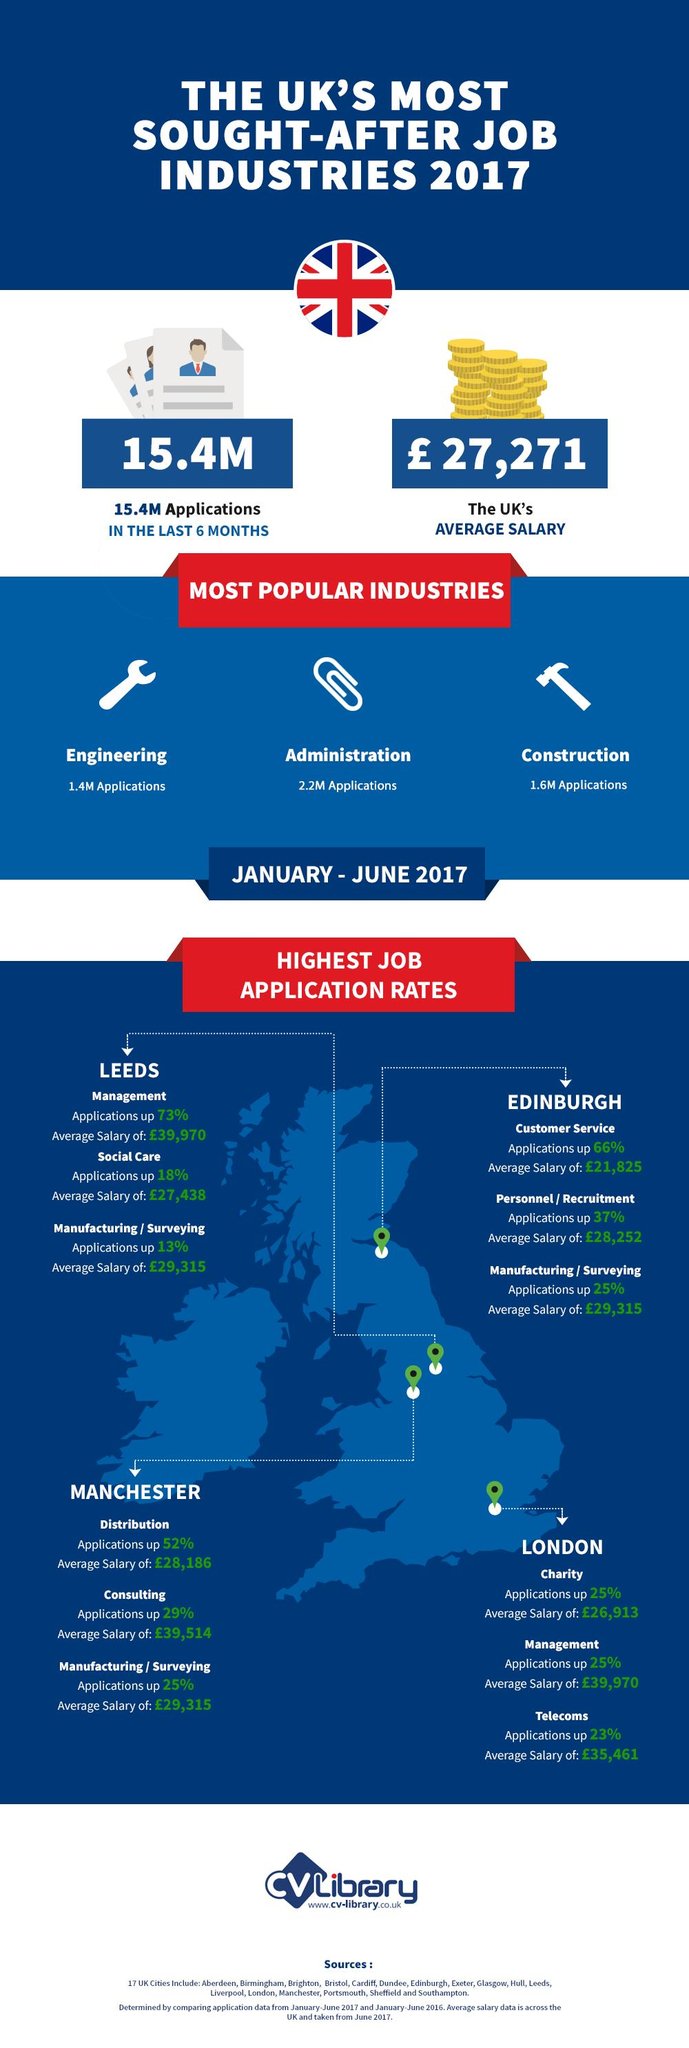Give some essential details in this illustration. The industry in Manchester with the highest increase in job application rate from January to June 2017 was distribution. The average salary of Telecom jobs in London from January-June 2017 was £35,461. The average salary of customer service jobs in Edinburgh from January to June 2017 was £21,825. The average salary in the UK in 2017 was £27,271. The average salary of social care jobs in Leeds from January to June 2017 was £27,432. 